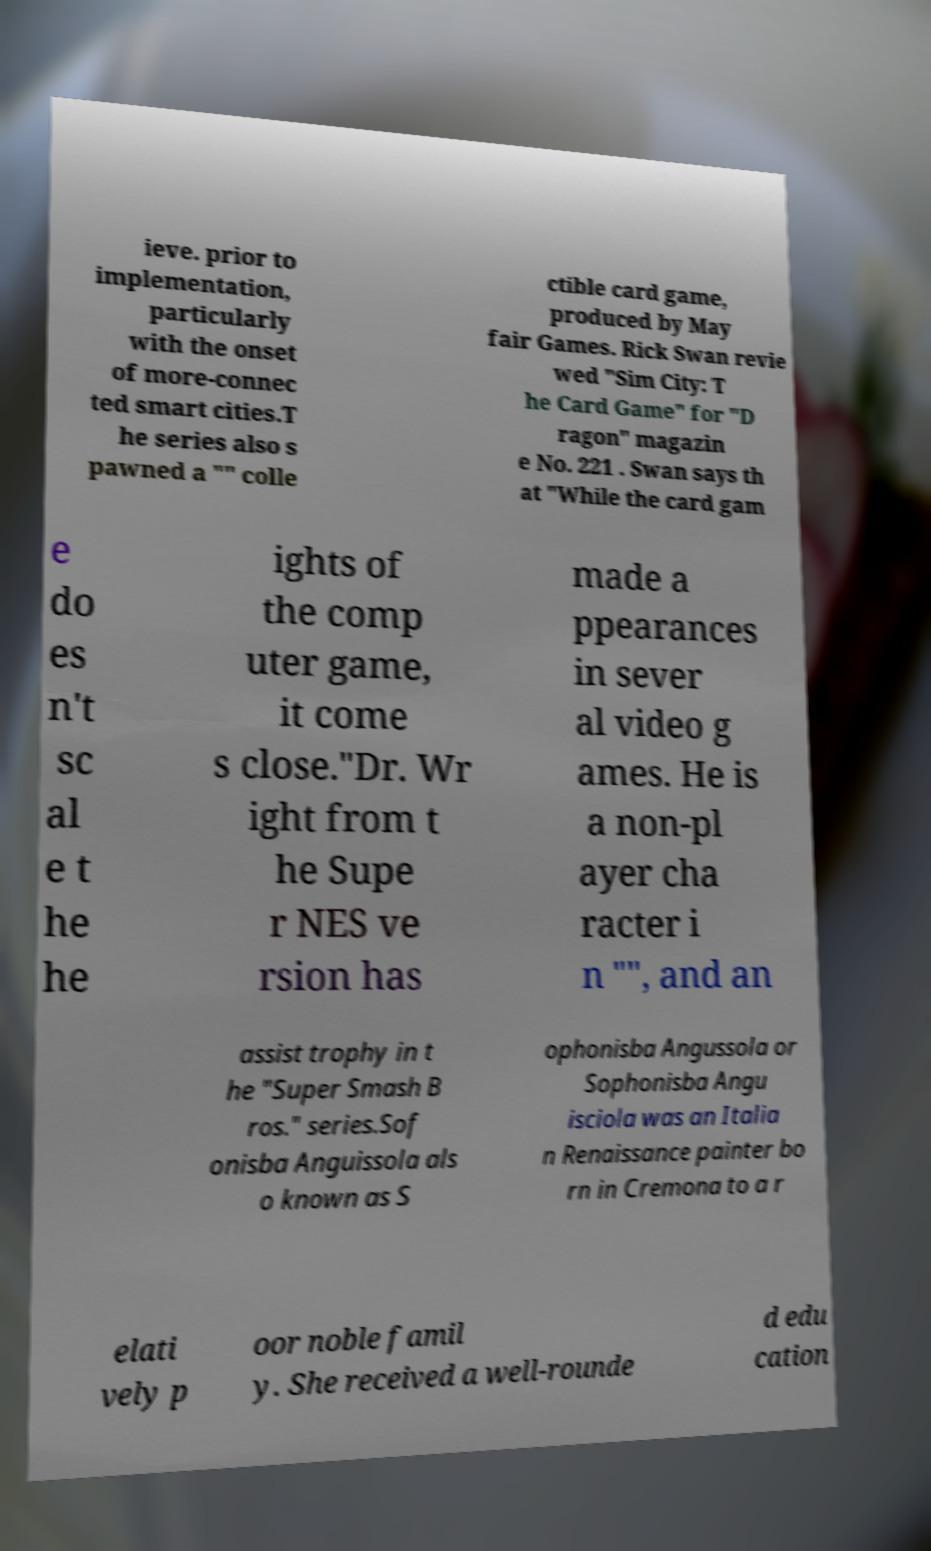Could you extract and type out the text from this image? ieve. prior to implementation, particularly with the onset of more-connec ted smart cities.T he series also s pawned a "" colle ctible card game, produced by May fair Games. Rick Swan revie wed "Sim City: T he Card Game" for "D ragon" magazin e No. 221 . Swan says th at "While the card gam e do es n't sc al e t he he ights of the comp uter game, it come s close."Dr. Wr ight from t he Supe r NES ve rsion has made a ppearances in sever al video g ames. He is a non-pl ayer cha racter i n "", and an assist trophy in t he "Super Smash B ros." series.Sof onisba Anguissola als o known as S ophonisba Angussola or Sophonisba Angu isciola was an Italia n Renaissance painter bo rn in Cremona to a r elati vely p oor noble famil y. She received a well-rounde d edu cation 